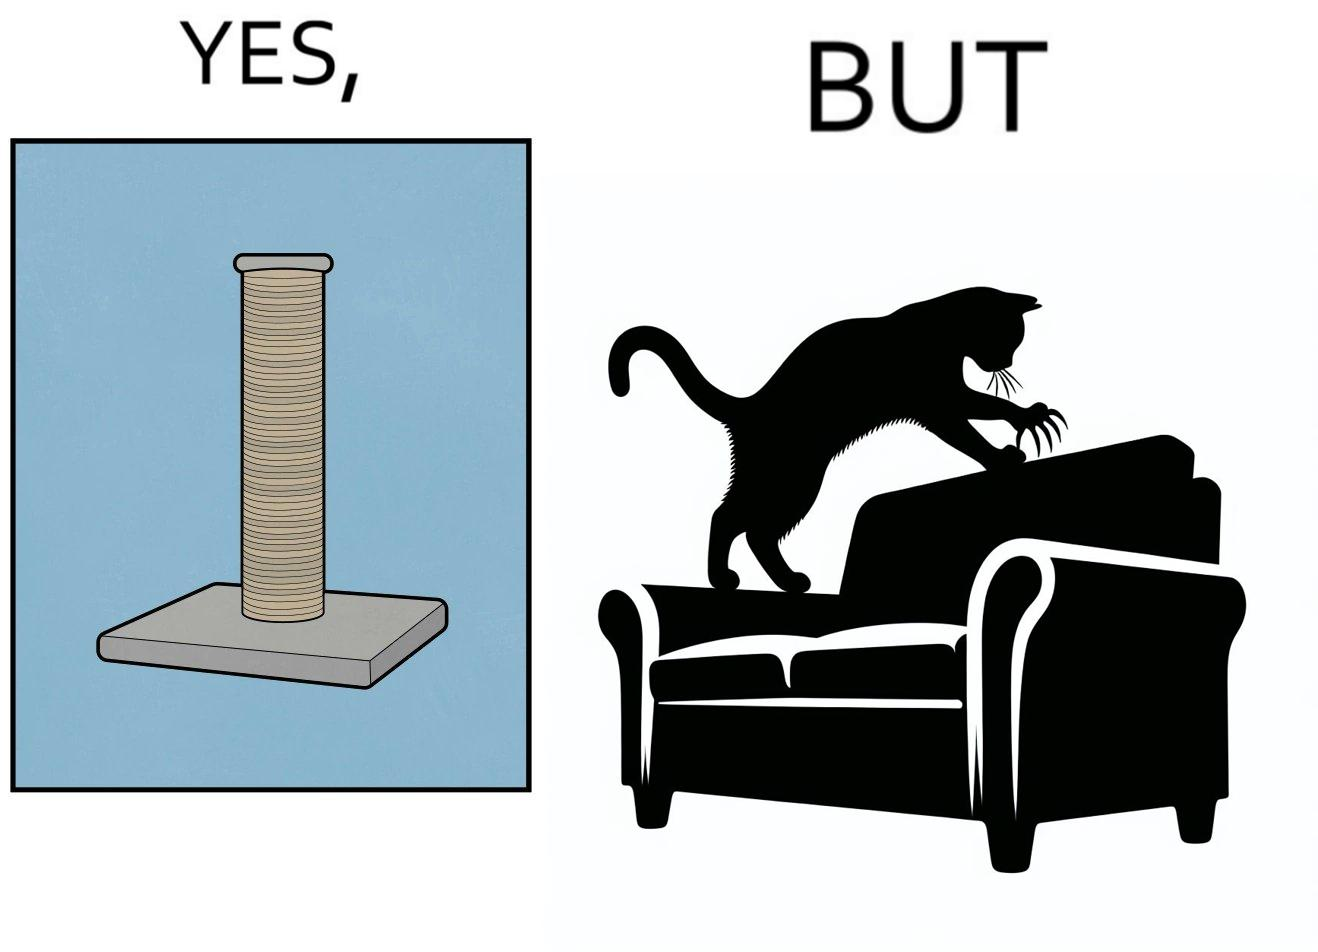What is shown in this image? The image is ironic, because in the first image a toy, purposed for the cat to play with is shown but in the second image the cat is comfortably enjoying  to play on the sides of sofa 